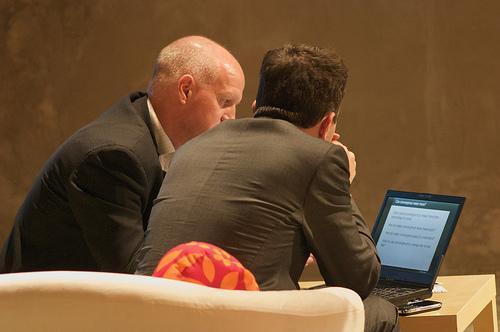How many men are there?
Give a very brief answer. 2. How many cushions are in the photo?
Give a very brief answer. 1. 